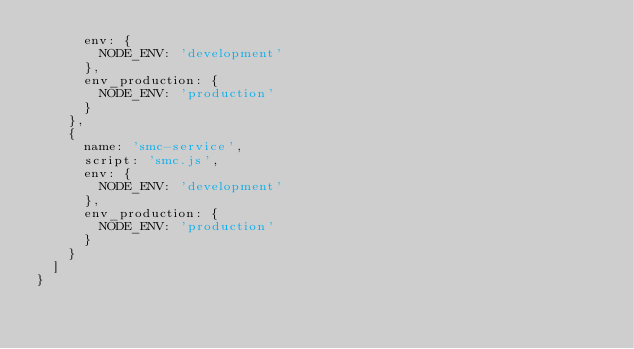Convert code to text. <code><loc_0><loc_0><loc_500><loc_500><_JavaScript_>      env: {
        NODE_ENV: 'development'
      },
      env_production: {
        NODE_ENV: 'production'
      }
    },
    {
      name: 'smc-service',
      script: 'smc.js',
      env: {
        NODE_ENV: 'development'
      },
      env_production: {
        NODE_ENV: 'production'
      }
    }
  ]
}
</code> 